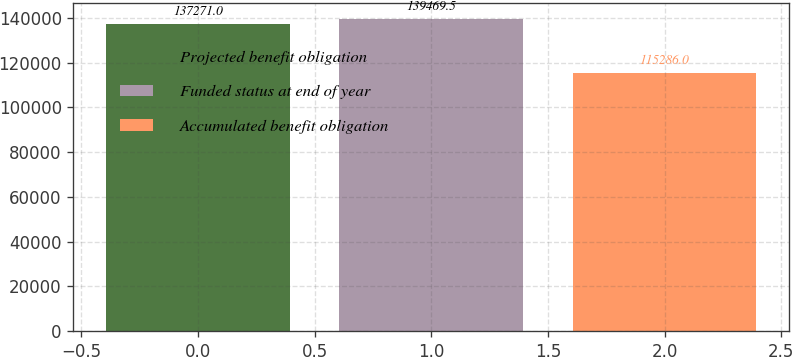Convert chart to OTSL. <chart><loc_0><loc_0><loc_500><loc_500><bar_chart><fcel>Projected benefit obligation<fcel>Funded status at end of year<fcel>Accumulated benefit obligation<nl><fcel>137271<fcel>139470<fcel>115286<nl></chart> 